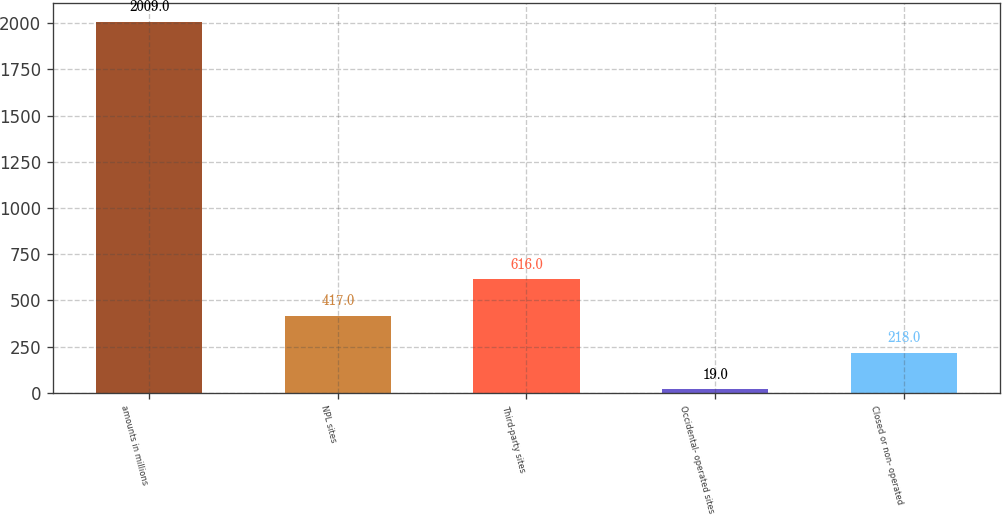Convert chart to OTSL. <chart><loc_0><loc_0><loc_500><loc_500><bar_chart><fcel>amounts in millions<fcel>NPL sites<fcel>Third-party sites<fcel>Occidental- operated sites<fcel>Closed or non- operated<nl><fcel>2009<fcel>417<fcel>616<fcel>19<fcel>218<nl></chart> 